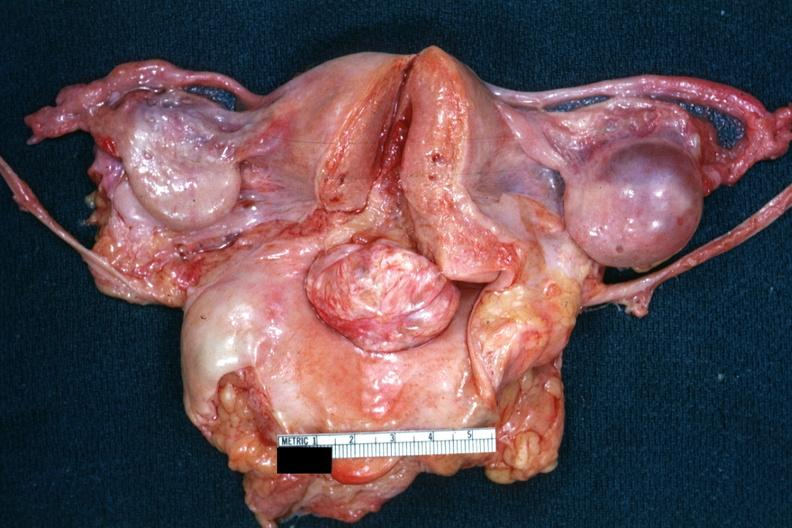what is present?
Answer the question using a single word or phrase. Female reproductive 